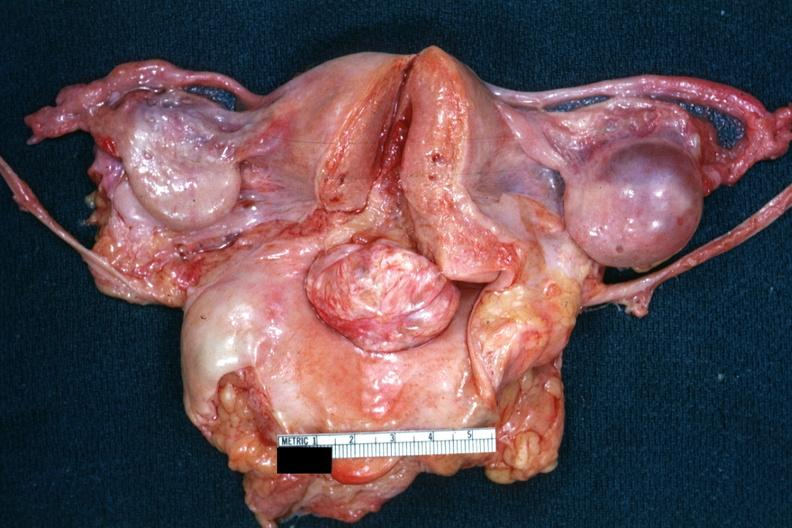what is present?
Answer the question using a single word or phrase. Female reproductive 